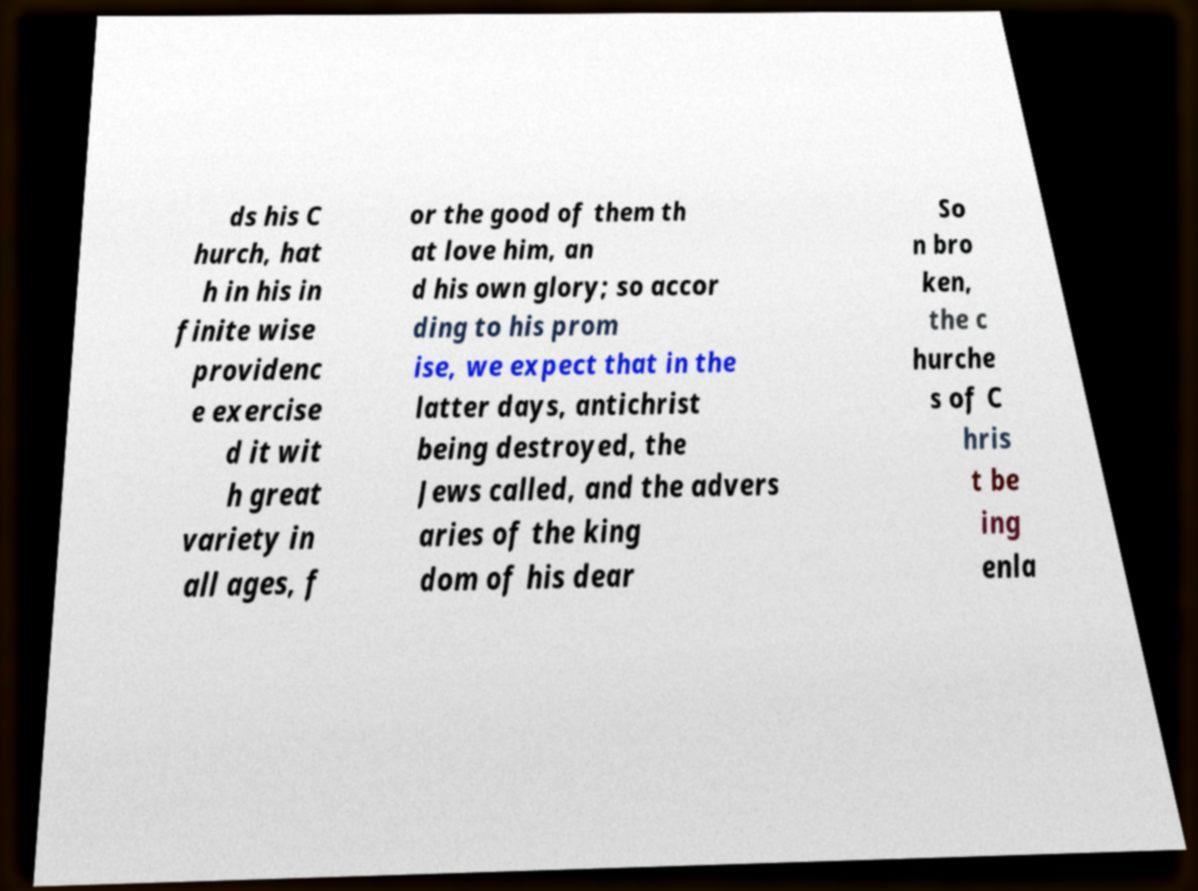I need the written content from this picture converted into text. Can you do that? ds his C hurch, hat h in his in finite wise providenc e exercise d it wit h great variety in all ages, f or the good of them th at love him, an d his own glory; so accor ding to his prom ise, we expect that in the latter days, antichrist being destroyed, the Jews called, and the advers aries of the king dom of his dear So n bro ken, the c hurche s of C hris t be ing enla 